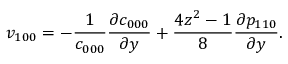<formula> <loc_0><loc_0><loc_500><loc_500>v _ { 1 0 0 } = - \frac { 1 } { c _ { 0 0 0 } } \frac { \partial c _ { 0 0 0 } } { \partial y } + \frac { 4 z ^ { 2 } - 1 } { 8 } \frac { \partial p _ { 1 1 0 } } { \partial y } .</formula> 